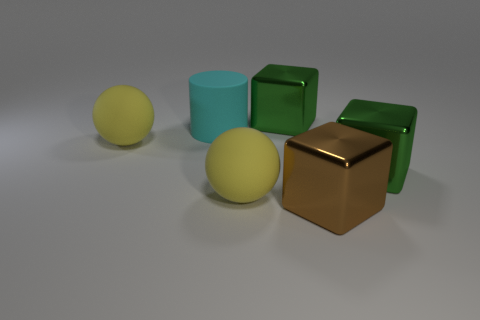Add 2 big yellow things. How many objects exist? 8 Subtract all spheres. How many objects are left? 4 Add 5 blocks. How many blocks are left? 8 Add 5 green blocks. How many green blocks exist? 7 Subtract 0 cyan balls. How many objects are left? 6 Subtract all big things. Subtract all large yellow shiny cylinders. How many objects are left? 0 